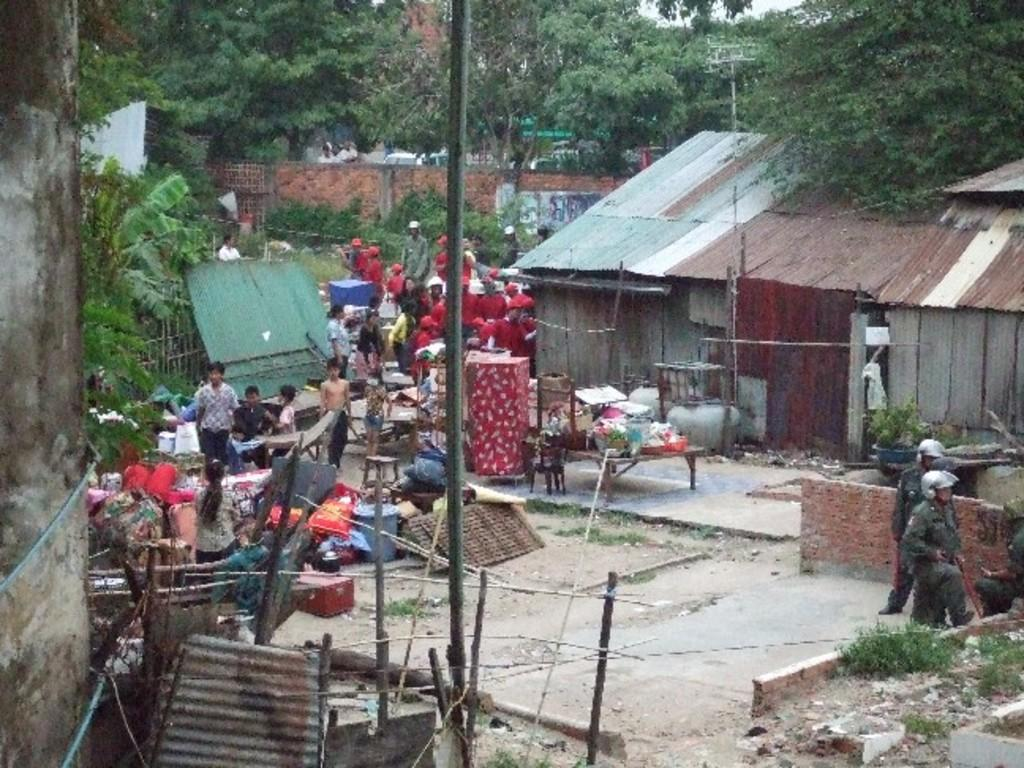How many people are in the image? There is a group of people standing in the image. What type of furniture is present in the image? There are chairs in the image. What other objects can be seen in the image besides the chairs? There are other objects in the image. What type of structure is visible in the image? There is a house in the image. What architectural features are present in the image? There are walls in the image. What type of barrier is present in the image? There is a fence in the image. What can be seen in the background of the image? There are trees in the background of the image. Where is the hen located in the image? There is no hen present in the image. What type of playground equipment can be seen in the image? There is no playground equipment present in the image. 